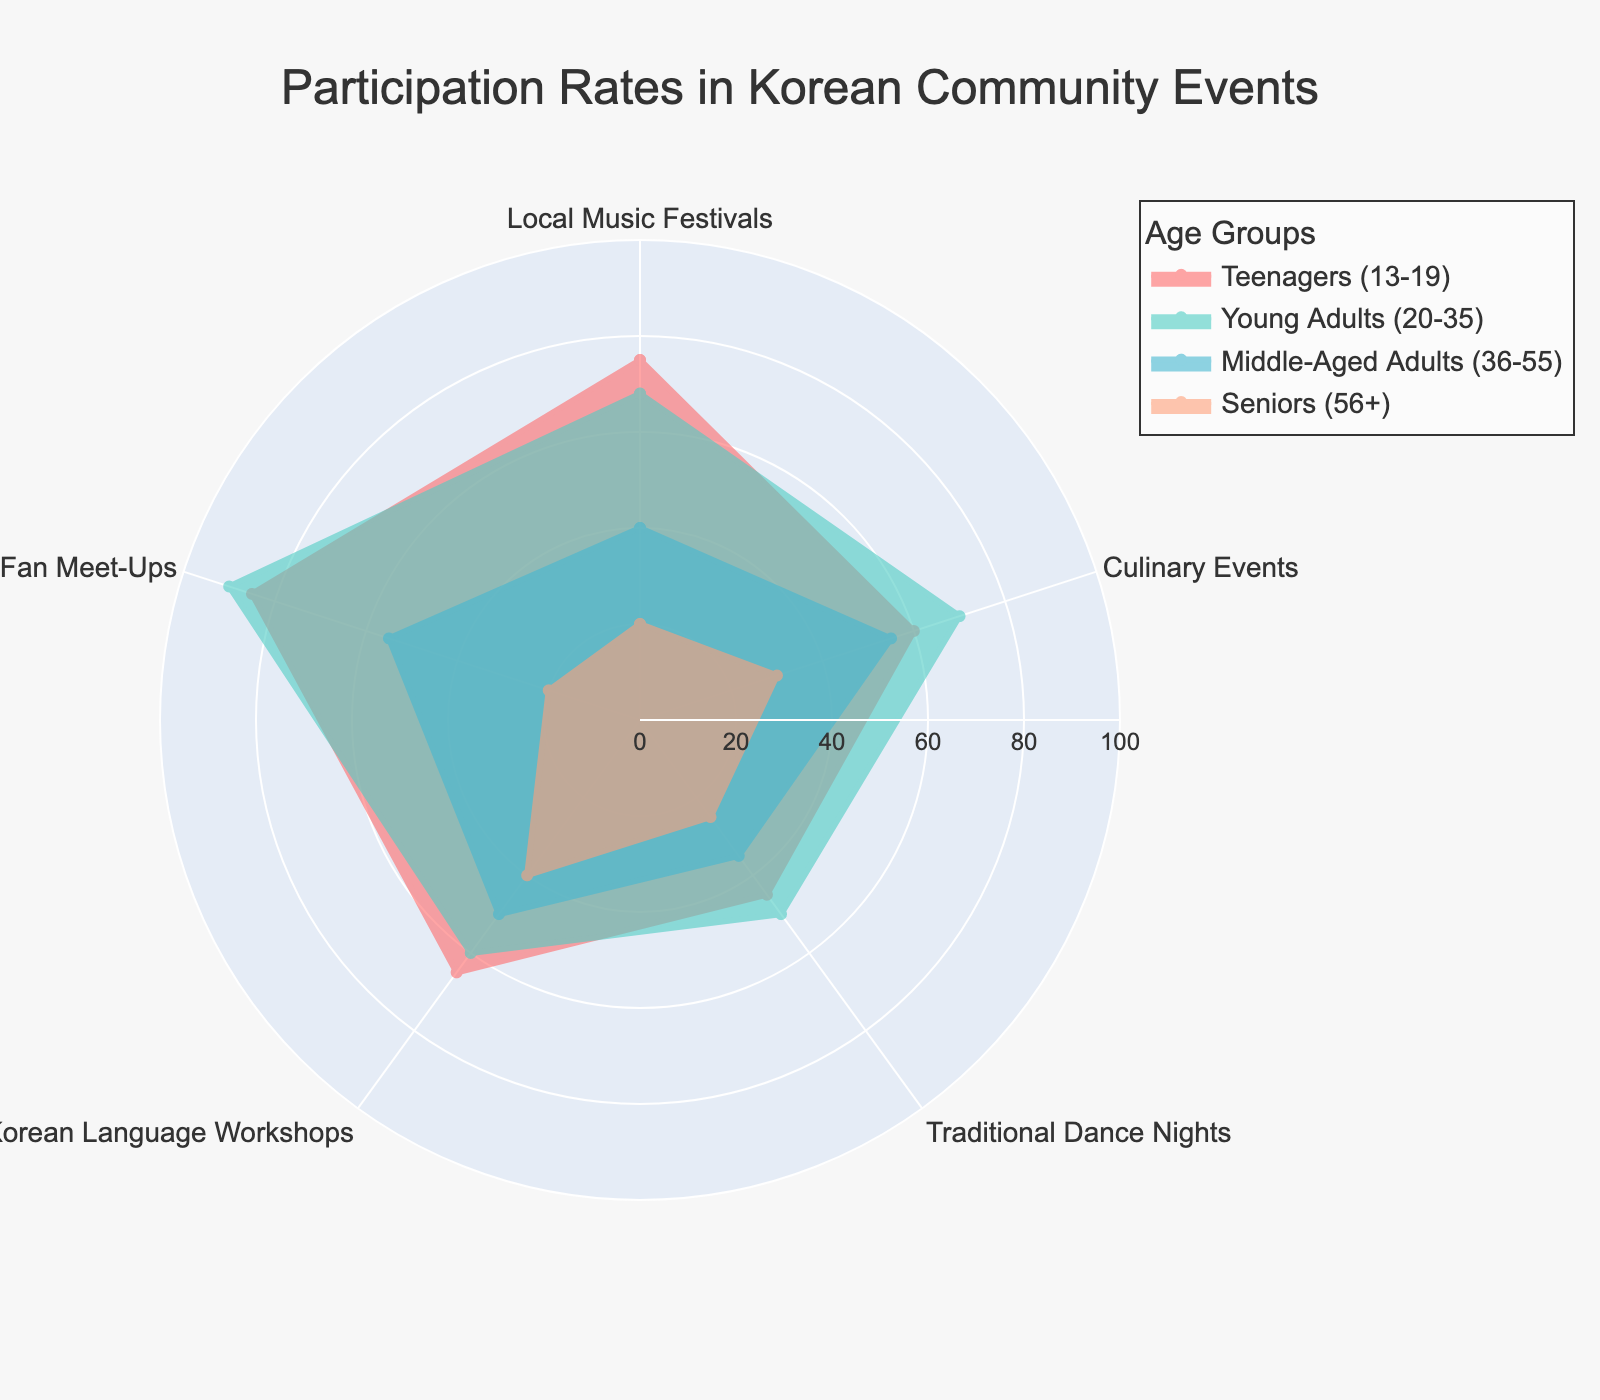How many age groups are represented in the radar chart? The title and legend indicate that the chart represents different age groups. By looking at the legend, we can count each age group: Teenagers (13-19), Young Adults (20-35), Middle-Aged Adults (36-55), and Seniors (56+). Therefore, there are four age groups.
Answer: Four Which age group has the highest participation rate in K-pop Fan Meet-Ups? We follow the colored lines and dots in the radar chart representing each age group's participation rate in various events. By focusing on the K-pop Fan Meet-Ups section, we see that the line representing Young Adults (20-35) reaches the highest value, which is 90.
Answer: Young Adults (20-35) What's the average participation rate of Teenagers (13-19) across all events? To find the average participation rate, sum the percentages for Teenagers (13-19): (75 + 60 + 45 + 65 + 85 = 330). Then, divide by the number of events, which is 5: 330 / 5 = 66.
Answer: 66 Which event has the lowest participation rate for Seniors (56+)? By examining the circumference representing Seniors (56+) in the radar chart, we look for the smallest value among all events. Traditional Dance Nights and K-pop Fan Meet-Ups both have a value of 20, but the lowest linked event is K-pop Fan Meet-Ups.
Answer: K-pop Fan Meet-Ups Compare the participation rates of Young Adults (20-35) and Middle-Aged Adults (36-55) in Korean Language Workshops. Which group participates more? The participation rate for Young Adults (20-35) in Korean Language Workshops is 60, and for Middle-Aged Adults (36-55), it is 50. Comparing these values shows that Young Adults (20-35) have a higher participation rate.
Answer: Young Adults (20-35) What's the range of participation rates in Culinary Events for all age groups? We identify the participation rates for Culinary Events among all age groups: Teenagers (60), Young Adults (70), Middle-Aged Adults (55), and Seniors (30). The range is the difference between the maximum and minimum rates: 70 - 30 = 40.
Answer: 40 Which age group participates most evenly among all events, and how did you determine this? To determine even participation, we observe which age group's radar chart line is most circular and evenly distributed among all categories. By visual observation, the Middle-Aged Adults (36-55) show relatively even participation rates (40, 55, 35, 50, 55), with fewer extreme values compared to other groups.
Answer: Middle-Aged Adults (36-55) Between Local Music Festivals and Traditional Dance Nights, which event sees a higher participation rate for Teenagers (13-19)? Observing the values for Teenagers in the chart, Local Music Festivals have a rate of 75, while Traditional Dance Nights have a rate of 45. Local Music Festivals have a higher participation rate.
Answer: Local Music Festivals 